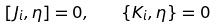<formula> <loc_0><loc_0><loc_500><loc_500>\left [ J _ { i } , \eta \right ] = 0 , \quad \left \{ K _ { i } , \eta \right \} = 0</formula> 